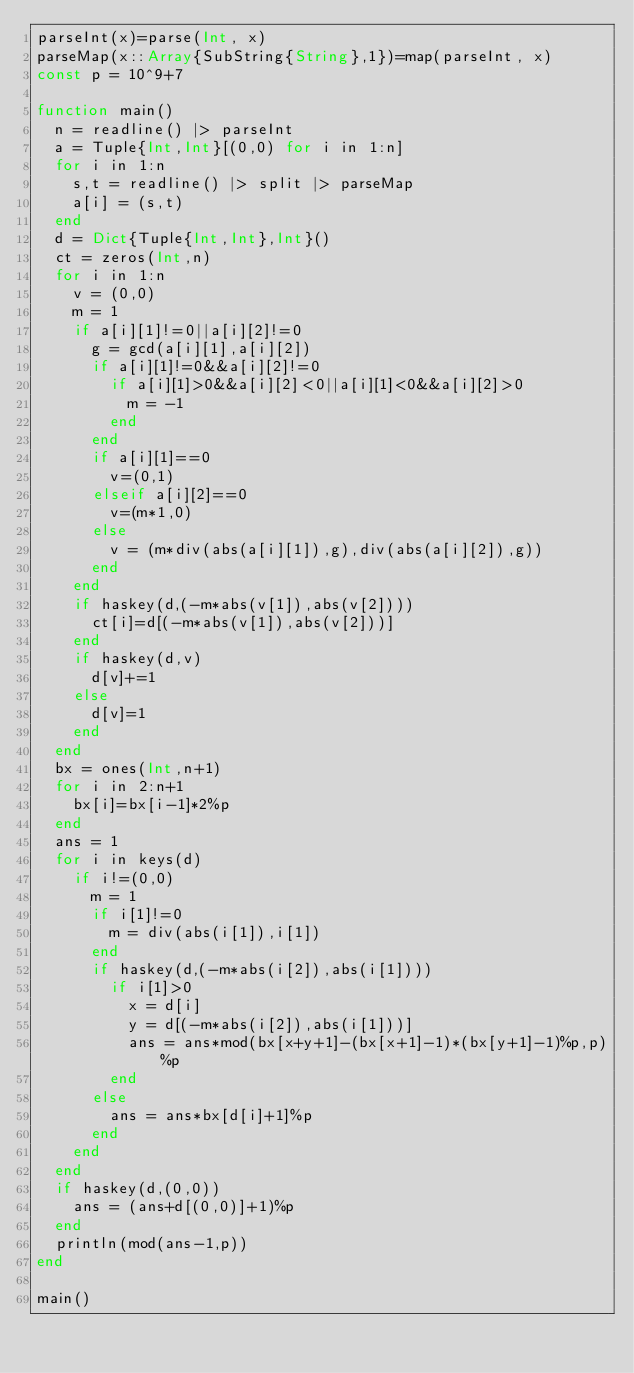Convert code to text. <code><loc_0><loc_0><loc_500><loc_500><_Julia_>parseInt(x)=parse(Int, x)
parseMap(x::Array{SubString{String},1})=map(parseInt, x)
const p = 10^9+7

function main()
	n = readline() |> parseInt
	a = Tuple{Int,Int}[(0,0) for i in 1:n]
	for i in 1:n
		s,t = readline() |> split |> parseMap
		a[i] = (s,t)
	end
	d = Dict{Tuple{Int,Int},Int}()
	ct = zeros(Int,n)
	for i in 1:n
		v = (0,0)
		m = 1
		if a[i][1]!=0||a[i][2]!=0
			g = gcd(a[i][1],a[i][2])
			if a[i][1]!=0&&a[i][2]!=0
				if a[i][1]>0&&a[i][2]<0||a[i][1]<0&&a[i][2]>0
					m = -1
				end
			end
			if a[i][1]==0
				v=(0,1)
			elseif a[i][2]==0
				v=(m*1,0)
			else
				v = (m*div(abs(a[i][1]),g),div(abs(a[i][2]),g))
			end
		end
		if haskey(d,(-m*abs(v[1]),abs(v[2])))
			ct[i]=d[(-m*abs(v[1]),abs(v[2]))]
		end
		if haskey(d,v)
			d[v]+=1
		else
			d[v]=1
		end
	end
	bx = ones(Int,n+1)
	for i in 2:n+1
		bx[i]=bx[i-1]*2%p
	end
	ans = 1
	for i in keys(d)
		if i!=(0,0)
			m = 1
			if i[1]!=0
				m = div(abs(i[1]),i[1])
			end
			if haskey(d,(-m*abs(i[2]),abs(i[1])))
				if i[1]>0
					x = d[i]
					y = d[(-m*abs(i[2]),abs(i[1]))]
					ans = ans*mod(bx[x+y+1]-(bx[x+1]-1)*(bx[y+1]-1)%p,p)%p
				end
			else
				ans = ans*bx[d[i]+1]%p
			end
		end
	end
	if haskey(d,(0,0))
		ans = (ans+d[(0,0)]+1)%p
	end
	println(mod(ans-1,p))
end

main()</code> 